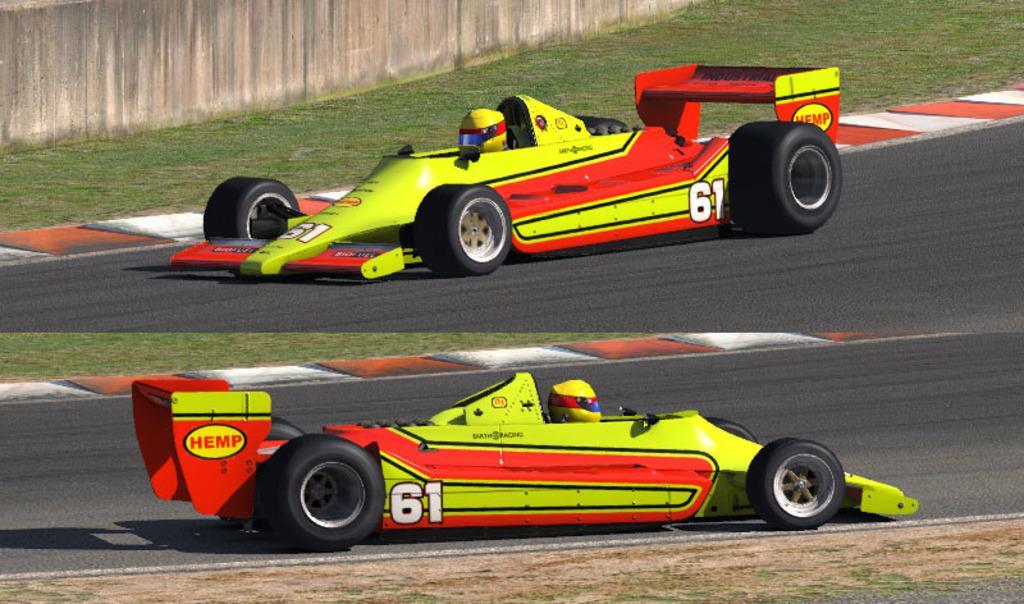In one or two sentences, can you explain what this image depicts? This image consists of go-kart. And there are persons riding these cars and wearing yellow color helmet. At the bottom, there is ground and road. In the background, there is a wall. The cars are in yellow and red color. 